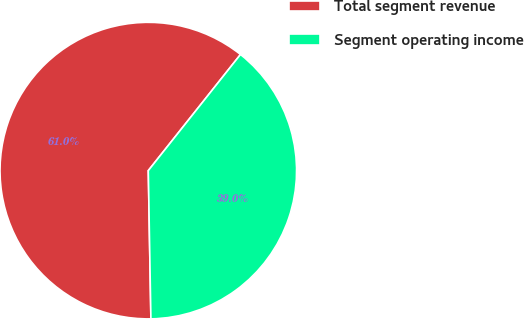<chart> <loc_0><loc_0><loc_500><loc_500><pie_chart><fcel>Total segment revenue<fcel>Segment operating income<nl><fcel>60.96%<fcel>39.04%<nl></chart> 